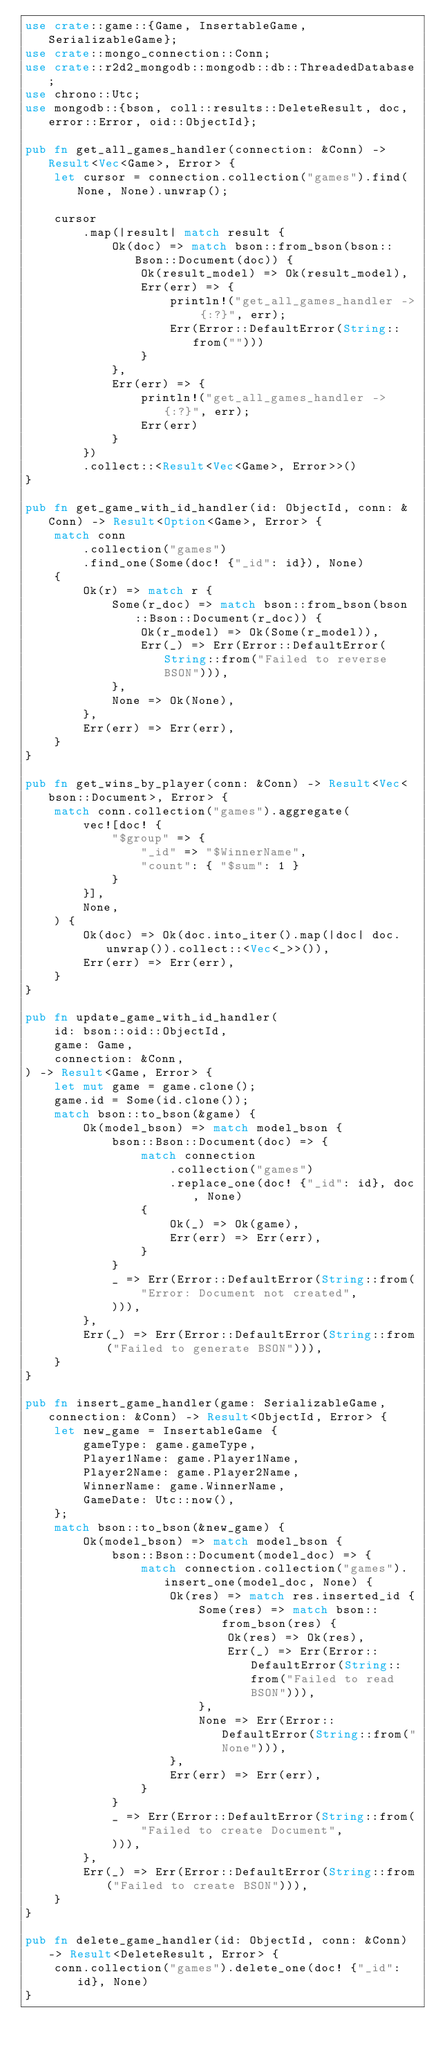Convert code to text. <code><loc_0><loc_0><loc_500><loc_500><_Rust_>use crate::game::{Game, InsertableGame, SerializableGame};
use crate::mongo_connection::Conn;
use crate::r2d2_mongodb::mongodb::db::ThreadedDatabase;
use chrono::Utc;
use mongodb::{bson, coll::results::DeleteResult, doc, error::Error, oid::ObjectId};

pub fn get_all_games_handler(connection: &Conn) -> Result<Vec<Game>, Error> {
    let cursor = connection.collection("games").find(None, None).unwrap();

    cursor
        .map(|result| match result {
            Ok(doc) => match bson::from_bson(bson::Bson::Document(doc)) {
                Ok(result_model) => Ok(result_model),
                Err(err) => {
                    println!("get_all_games_handler -> {:?}", err);
                    Err(Error::DefaultError(String::from("")))
                }
            },
            Err(err) => {
                println!("get_all_games_handler -> {:?}", err);
                Err(err)
            }
        })
        .collect::<Result<Vec<Game>, Error>>()
}

pub fn get_game_with_id_handler(id: ObjectId, conn: &Conn) -> Result<Option<Game>, Error> {
    match conn
        .collection("games")
        .find_one(Some(doc! {"_id": id}), None)
    {
        Ok(r) => match r {
            Some(r_doc) => match bson::from_bson(bson::Bson::Document(r_doc)) {
                Ok(r_model) => Ok(Some(r_model)),
                Err(_) => Err(Error::DefaultError(String::from("Failed to reverse BSON"))),
            },
            None => Ok(None),
        },
        Err(err) => Err(err),
    }
}

pub fn get_wins_by_player(conn: &Conn) -> Result<Vec<bson::Document>, Error> {
    match conn.collection("games").aggregate(
        vec![doc! {
            "$group" => {
                "_id" => "$WinnerName",
                "count": { "$sum": 1 }
            }
        }],
        None,
    ) {
        Ok(doc) => Ok(doc.into_iter().map(|doc| doc.unwrap()).collect::<Vec<_>>()),
        Err(err) => Err(err),
    }
}

pub fn update_game_with_id_handler(
    id: bson::oid::ObjectId,
    game: Game,
    connection: &Conn,
) -> Result<Game, Error> {
    let mut game = game.clone();
    game.id = Some(id.clone());
    match bson::to_bson(&game) {
        Ok(model_bson) => match model_bson {
            bson::Bson::Document(doc) => {
                match connection
                    .collection("games")
                    .replace_one(doc! {"_id": id}, doc, None)
                {
                    Ok(_) => Ok(game),
                    Err(err) => Err(err),
                }
            }
            _ => Err(Error::DefaultError(String::from(
                "Error: Document not created",
            ))),
        },
        Err(_) => Err(Error::DefaultError(String::from("Failed to generate BSON"))),
    }
}

pub fn insert_game_handler(game: SerializableGame, connection: &Conn) -> Result<ObjectId, Error> {
    let new_game = InsertableGame {
        gameType: game.gameType,
        Player1Name: game.Player1Name,
        Player2Name: game.Player2Name,
        WinnerName: game.WinnerName,
        GameDate: Utc::now(),
    };
    match bson::to_bson(&new_game) {
        Ok(model_bson) => match model_bson {
            bson::Bson::Document(model_doc) => {
                match connection.collection("games").insert_one(model_doc, None) {
                    Ok(res) => match res.inserted_id {
                        Some(res) => match bson::from_bson(res) {
                            Ok(res) => Ok(res),
                            Err(_) => Err(Error::DefaultError(String::from("Failed to read BSON"))),
                        },
                        None => Err(Error::DefaultError(String::from("None"))),
                    },
                    Err(err) => Err(err),
                }
            }
            _ => Err(Error::DefaultError(String::from(
                "Failed to create Document",
            ))),
        },
        Err(_) => Err(Error::DefaultError(String::from("Failed to create BSON"))),
    }
}

pub fn delete_game_handler(id: ObjectId, conn: &Conn) -> Result<DeleteResult, Error> {
    conn.collection("games").delete_one(doc! {"_id": id}, None)
}
</code> 